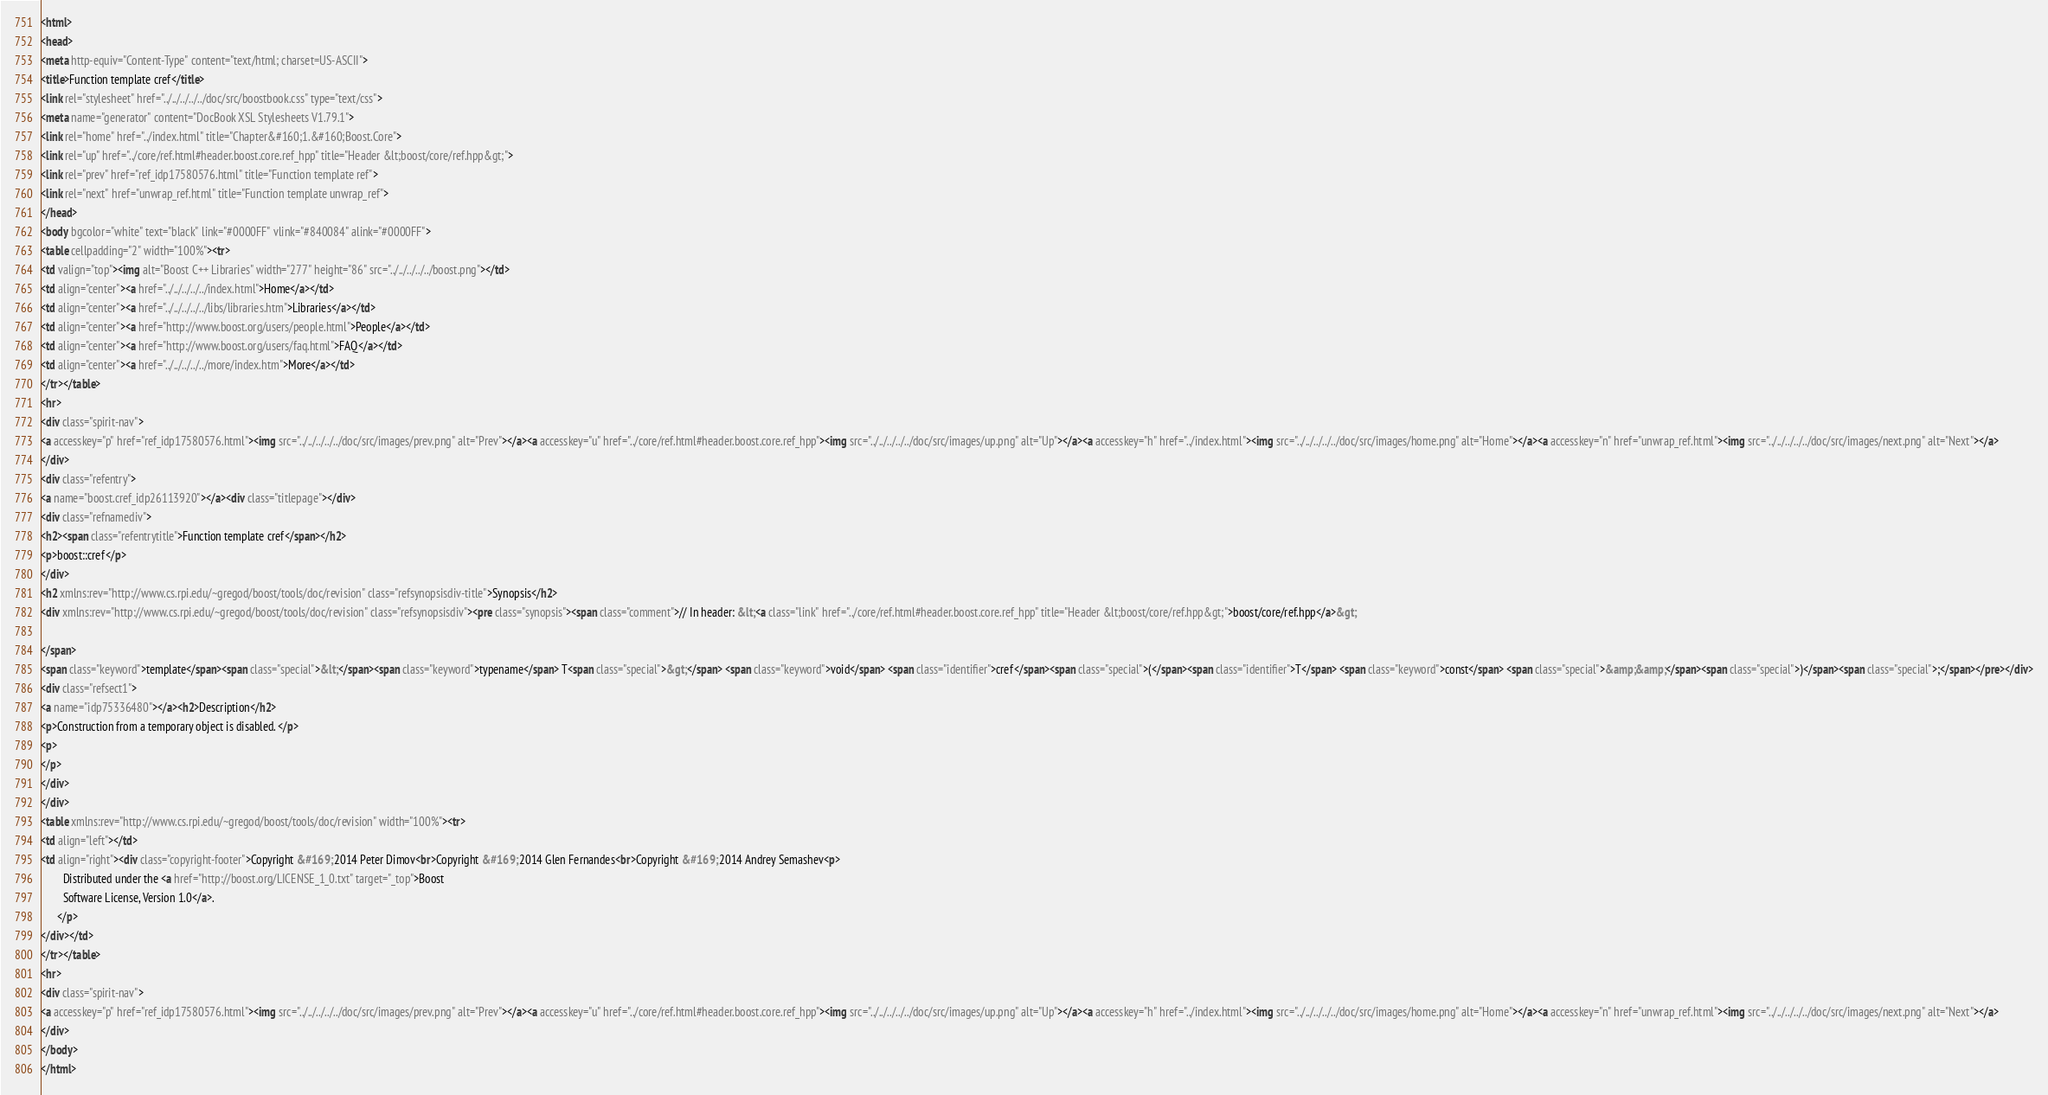Convert code to text. <code><loc_0><loc_0><loc_500><loc_500><_HTML_><html>
<head>
<meta http-equiv="Content-Type" content="text/html; charset=US-ASCII">
<title>Function template cref</title>
<link rel="stylesheet" href="../../../../../doc/src/boostbook.css" type="text/css">
<meta name="generator" content="DocBook XSL Stylesheets V1.79.1">
<link rel="home" href="../index.html" title="Chapter&#160;1.&#160;Boost.Core">
<link rel="up" href="../core/ref.html#header.boost.core.ref_hpp" title="Header &lt;boost/core/ref.hpp&gt;">
<link rel="prev" href="ref_idp17580576.html" title="Function template ref">
<link rel="next" href="unwrap_ref.html" title="Function template unwrap_ref">
</head>
<body bgcolor="white" text="black" link="#0000FF" vlink="#840084" alink="#0000FF">
<table cellpadding="2" width="100%"><tr>
<td valign="top"><img alt="Boost C++ Libraries" width="277" height="86" src="../../../../../boost.png"></td>
<td align="center"><a href="../../../../../index.html">Home</a></td>
<td align="center"><a href="../../../../../libs/libraries.htm">Libraries</a></td>
<td align="center"><a href="http://www.boost.org/users/people.html">People</a></td>
<td align="center"><a href="http://www.boost.org/users/faq.html">FAQ</a></td>
<td align="center"><a href="../../../../../more/index.htm">More</a></td>
</tr></table>
<hr>
<div class="spirit-nav">
<a accesskey="p" href="ref_idp17580576.html"><img src="../../../../../doc/src/images/prev.png" alt="Prev"></a><a accesskey="u" href="../core/ref.html#header.boost.core.ref_hpp"><img src="../../../../../doc/src/images/up.png" alt="Up"></a><a accesskey="h" href="../index.html"><img src="../../../../../doc/src/images/home.png" alt="Home"></a><a accesskey="n" href="unwrap_ref.html"><img src="../../../../../doc/src/images/next.png" alt="Next"></a>
</div>
<div class="refentry">
<a name="boost.cref_idp26113920"></a><div class="titlepage"></div>
<div class="refnamediv">
<h2><span class="refentrytitle">Function template cref</span></h2>
<p>boost::cref</p>
</div>
<h2 xmlns:rev="http://www.cs.rpi.edu/~gregod/boost/tools/doc/revision" class="refsynopsisdiv-title">Synopsis</h2>
<div xmlns:rev="http://www.cs.rpi.edu/~gregod/boost/tools/doc/revision" class="refsynopsisdiv"><pre class="synopsis"><span class="comment">// In header: &lt;<a class="link" href="../core/ref.html#header.boost.core.ref_hpp" title="Header &lt;boost/core/ref.hpp&gt;">boost/core/ref.hpp</a>&gt;

</span>
<span class="keyword">template</span><span class="special">&lt;</span><span class="keyword">typename</span> T<span class="special">&gt;</span> <span class="keyword">void</span> <span class="identifier">cref</span><span class="special">(</span><span class="identifier">T</span> <span class="keyword">const</span> <span class="special">&amp;&amp;</span><span class="special">)</span><span class="special">;</span></pre></div>
<div class="refsect1">
<a name="idp75336480"></a><h2>Description</h2>
<p>Construction from a temporary object is disabled. </p>
<p>
</p>
</div>
</div>
<table xmlns:rev="http://www.cs.rpi.edu/~gregod/boost/tools/doc/revision" width="100%"><tr>
<td align="left"></td>
<td align="right"><div class="copyright-footer">Copyright &#169; 2014 Peter Dimov<br>Copyright &#169; 2014 Glen Fernandes<br>Copyright &#169; 2014 Andrey Semashev<p>
        Distributed under the <a href="http://boost.org/LICENSE_1_0.txt" target="_top">Boost
        Software License, Version 1.0</a>.
      </p>
</div></td>
</tr></table>
<hr>
<div class="spirit-nav">
<a accesskey="p" href="ref_idp17580576.html"><img src="../../../../../doc/src/images/prev.png" alt="Prev"></a><a accesskey="u" href="../core/ref.html#header.boost.core.ref_hpp"><img src="../../../../../doc/src/images/up.png" alt="Up"></a><a accesskey="h" href="../index.html"><img src="../../../../../doc/src/images/home.png" alt="Home"></a><a accesskey="n" href="unwrap_ref.html"><img src="../../../../../doc/src/images/next.png" alt="Next"></a>
</div>
</body>
</html>
</code> 